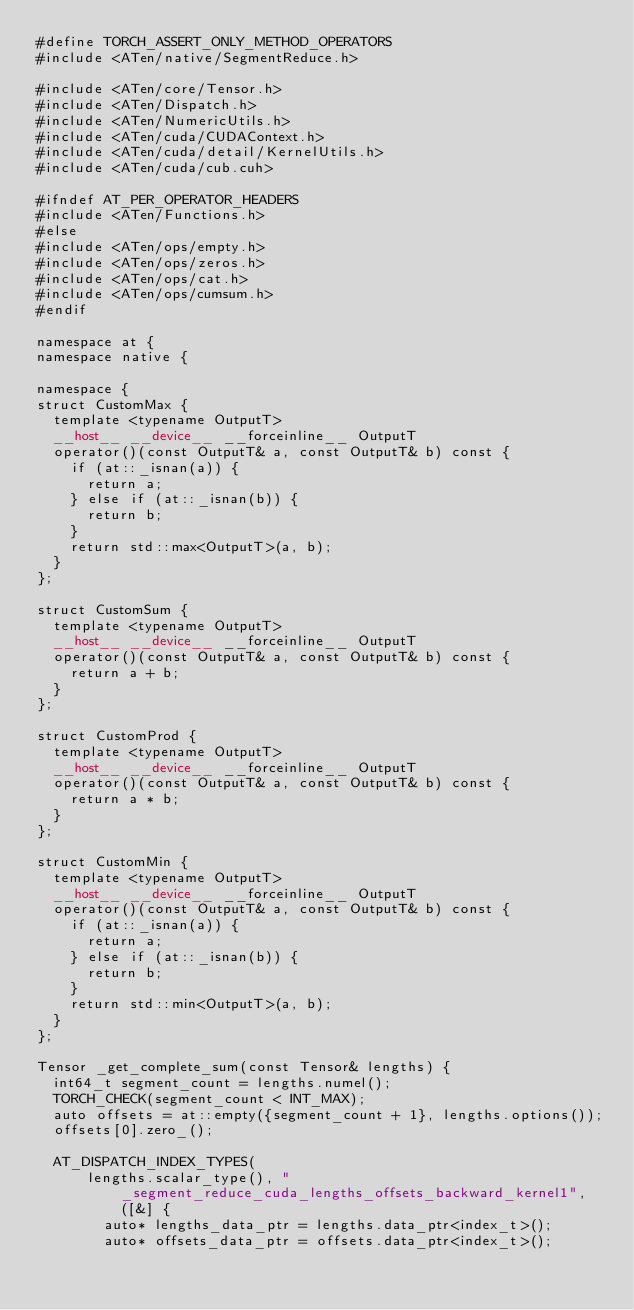Convert code to text. <code><loc_0><loc_0><loc_500><loc_500><_Cuda_>#define TORCH_ASSERT_ONLY_METHOD_OPERATORS
#include <ATen/native/SegmentReduce.h>

#include <ATen/core/Tensor.h>
#include <ATen/Dispatch.h>
#include <ATen/NumericUtils.h>
#include <ATen/cuda/CUDAContext.h>
#include <ATen/cuda/detail/KernelUtils.h>
#include <ATen/cuda/cub.cuh>

#ifndef AT_PER_OPERATOR_HEADERS
#include <ATen/Functions.h>
#else
#include <ATen/ops/empty.h>
#include <ATen/ops/zeros.h>
#include <ATen/ops/cat.h>
#include <ATen/ops/cumsum.h>
#endif

namespace at {
namespace native {

namespace {
struct CustomMax {
  template <typename OutputT>
  __host__ __device__ __forceinline__ OutputT
  operator()(const OutputT& a, const OutputT& b) const {
    if (at::_isnan(a)) {
      return a;
    } else if (at::_isnan(b)) {
      return b;
    }
    return std::max<OutputT>(a, b);
  }
};

struct CustomSum {
  template <typename OutputT>
  __host__ __device__ __forceinline__ OutputT
  operator()(const OutputT& a, const OutputT& b) const {
    return a + b;
  }
};

struct CustomProd {
  template <typename OutputT>
  __host__ __device__ __forceinline__ OutputT
  operator()(const OutputT& a, const OutputT& b) const {
    return a * b;
  }
};

struct CustomMin {
  template <typename OutputT>
  __host__ __device__ __forceinline__ OutputT
  operator()(const OutputT& a, const OutputT& b) const {
    if (at::_isnan(a)) {
      return a;
    } else if (at::_isnan(b)) {
      return b;
    }
    return std::min<OutputT>(a, b);
  }
};

Tensor _get_complete_sum(const Tensor& lengths) {
  int64_t segment_count = lengths.numel();
  TORCH_CHECK(segment_count < INT_MAX);
  auto offsets = at::empty({segment_count + 1}, lengths.options());
  offsets[0].zero_();

  AT_DISPATCH_INDEX_TYPES(
      lengths.scalar_type(), "_segment_reduce_cuda_lengths_offsets_backward_kernel1", ([&] {
        auto* lengths_data_ptr = lengths.data_ptr<index_t>();
        auto* offsets_data_ptr = offsets.data_ptr<index_t>();</code> 